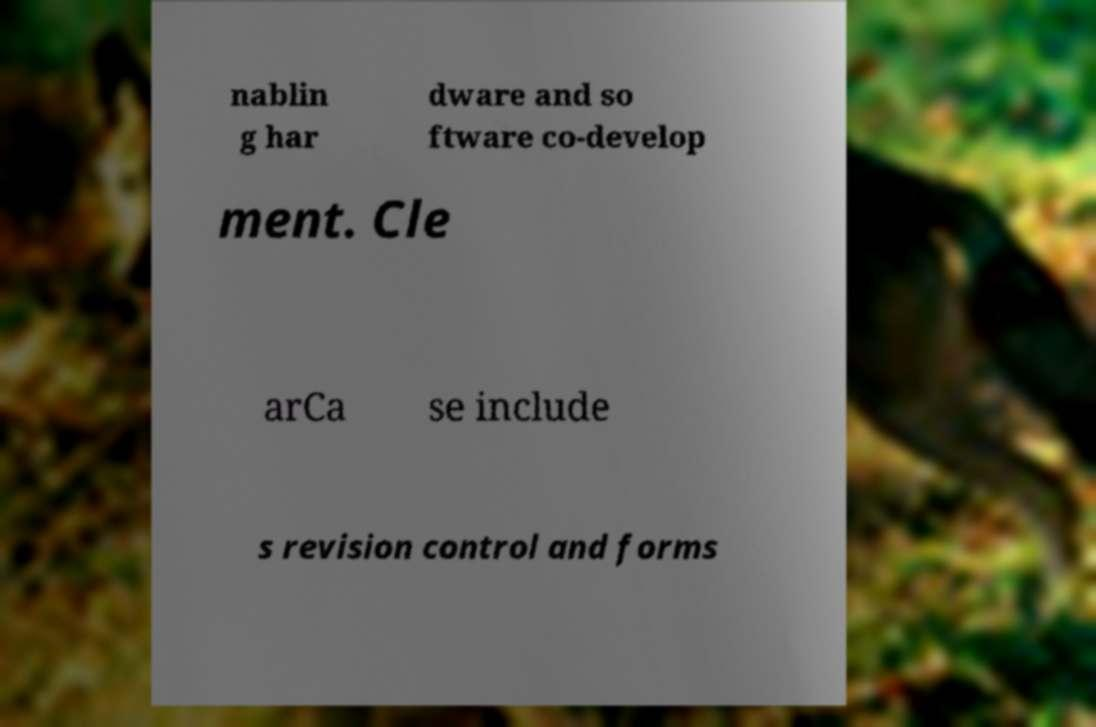I need the written content from this picture converted into text. Can you do that? nablin g har dware and so ftware co-develop ment. Cle arCa se include s revision control and forms 